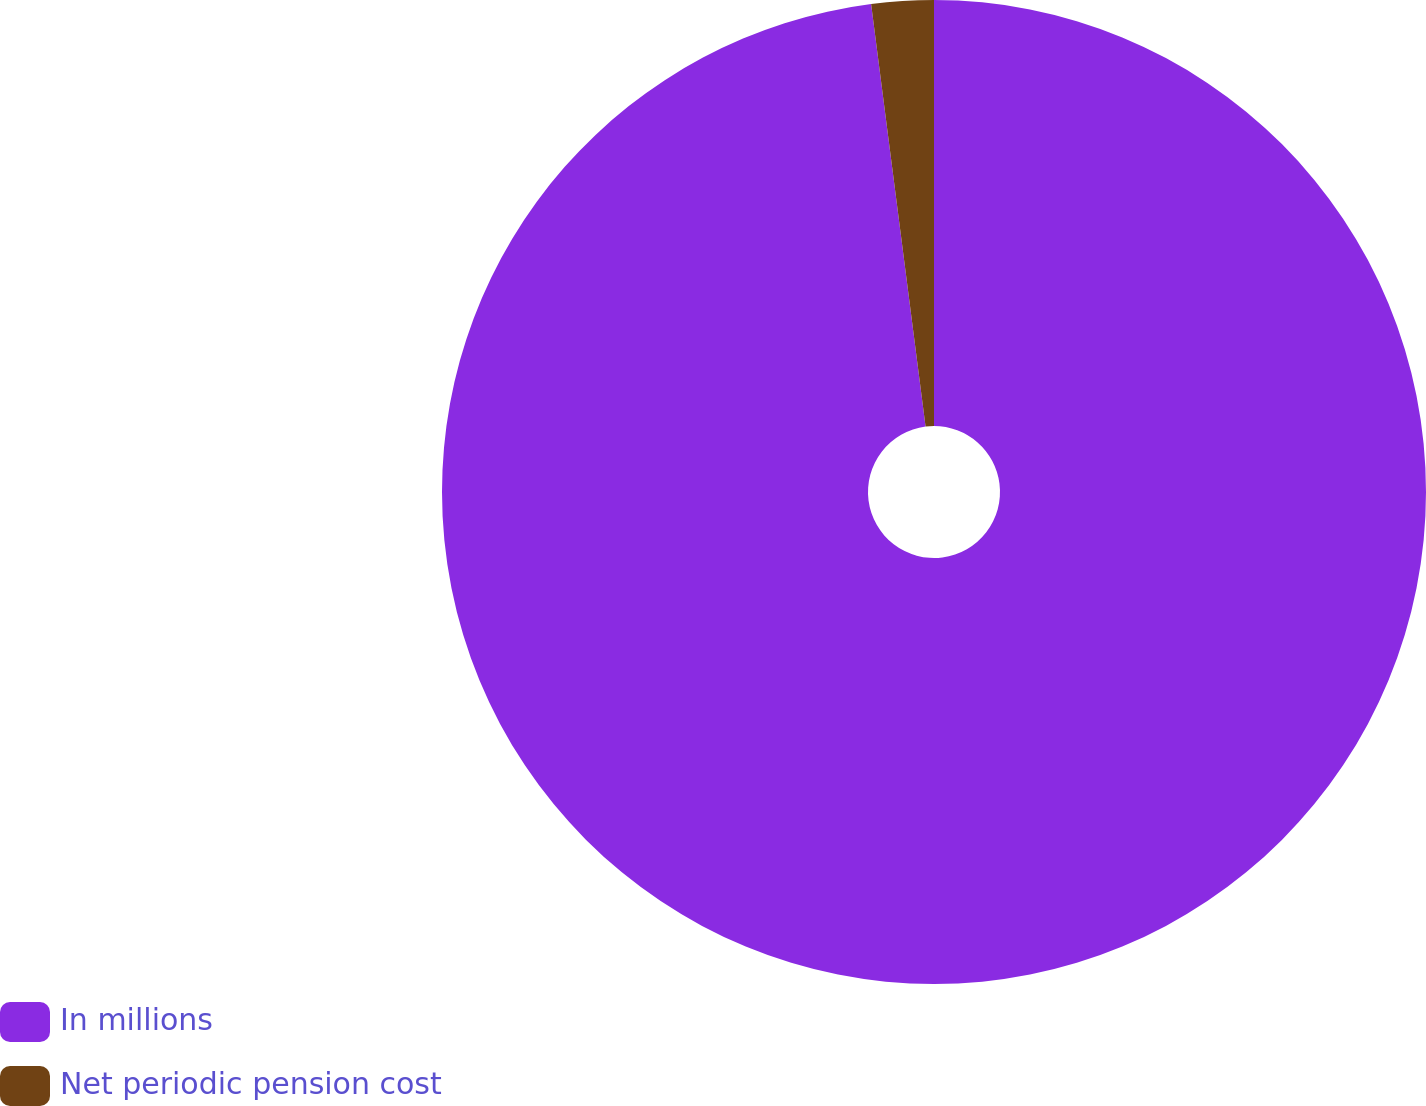Convert chart to OTSL. <chart><loc_0><loc_0><loc_500><loc_500><pie_chart><fcel>In millions<fcel>Net periodic pension cost<nl><fcel>97.96%<fcel>2.04%<nl></chart> 